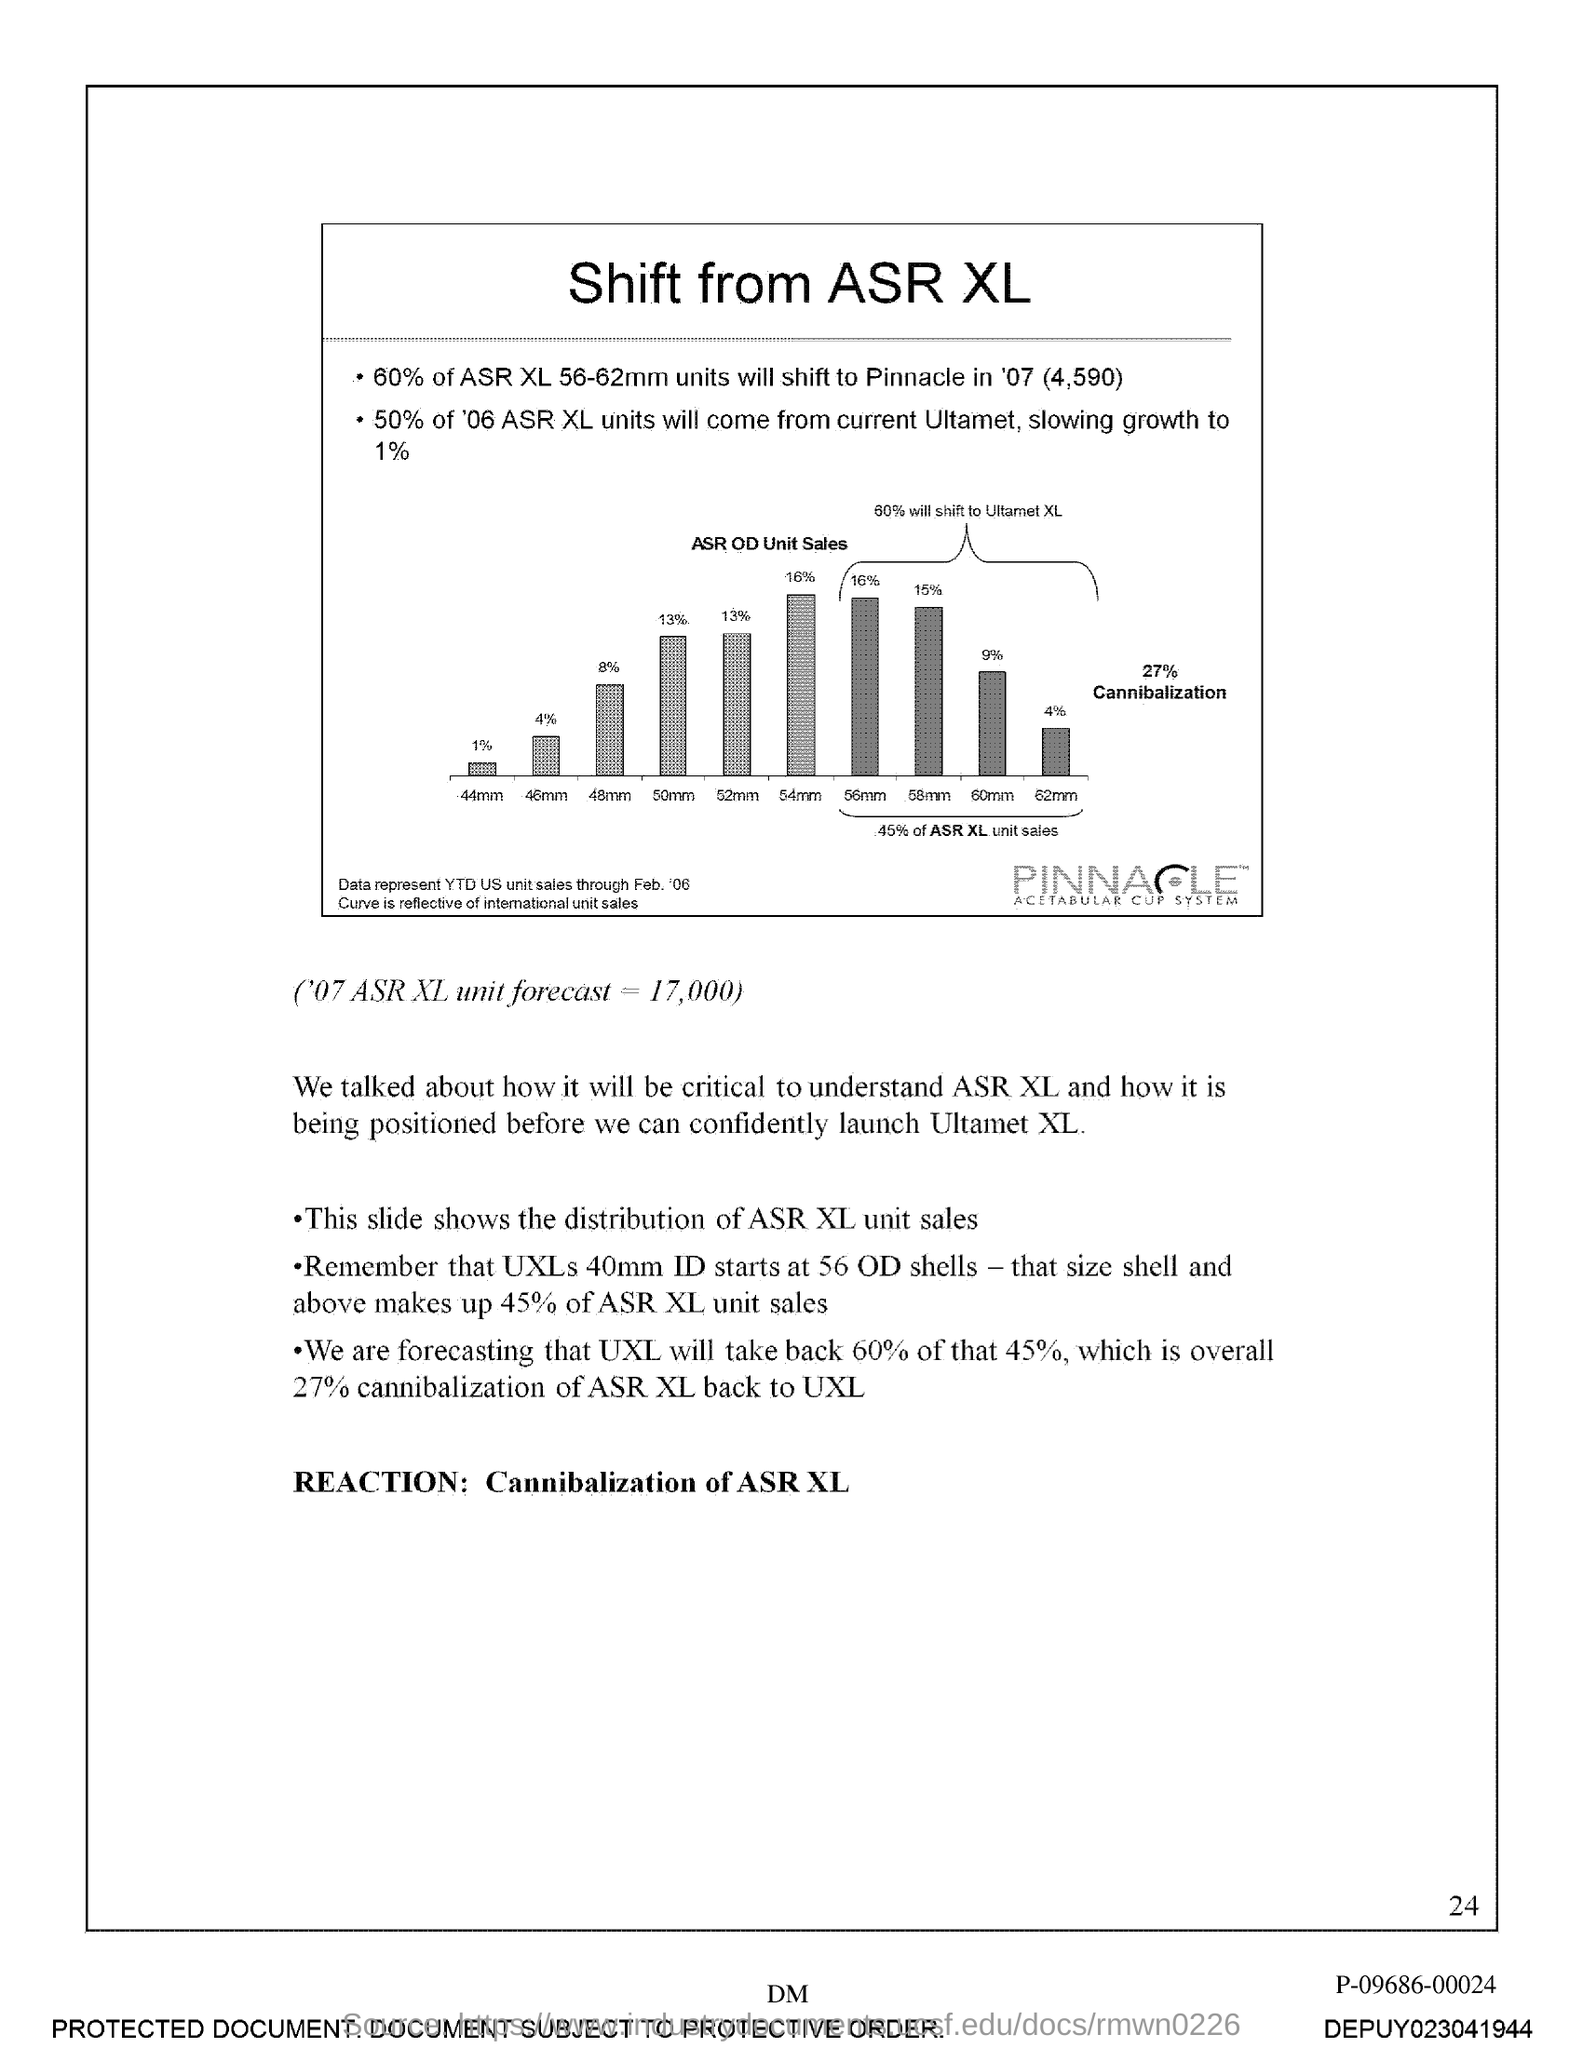Mention a couple of crucial points in this snapshot. Page 24 is the current page. 